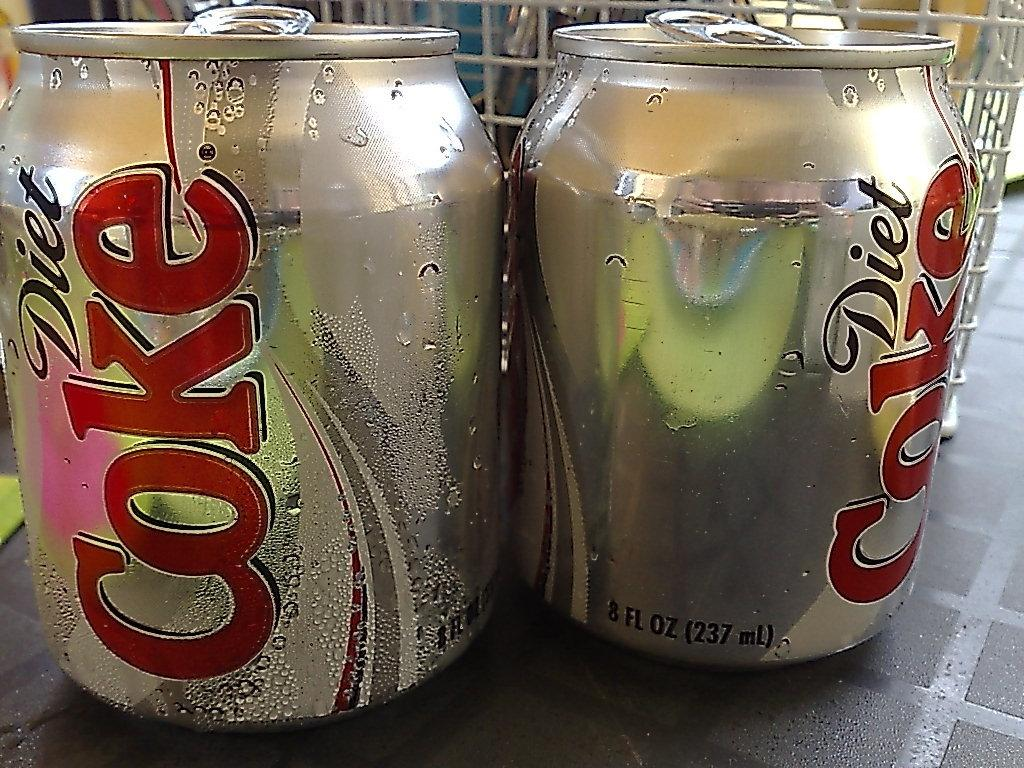<image>
Create a compact narrative representing the image presented. Two cans of diet coke are short and silver. 